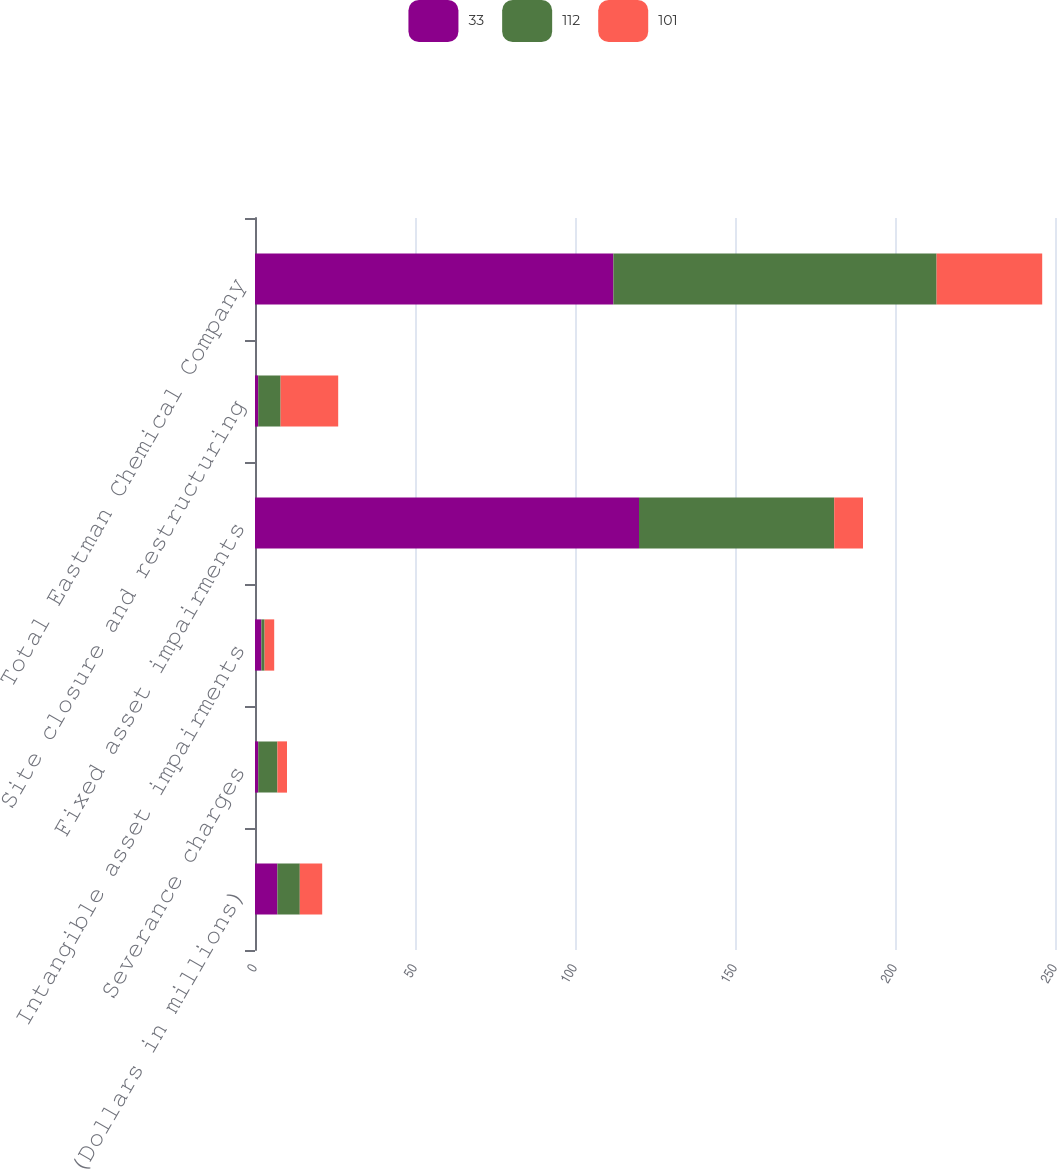Convert chart to OTSL. <chart><loc_0><loc_0><loc_500><loc_500><stacked_bar_chart><ecel><fcel>(Dollars in millions)<fcel>Severance charges<fcel>Intangible asset impairments<fcel>Fixed asset impairments<fcel>Site closure and restructuring<fcel>Total Eastman Chemical Company<nl><fcel>33<fcel>7<fcel>1<fcel>2<fcel>120<fcel>1<fcel>112<nl><fcel>112<fcel>7<fcel>6<fcel>1<fcel>61<fcel>7<fcel>101<nl><fcel>101<fcel>7<fcel>3<fcel>3<fcel>9<fcel>18<fcel>33<nl></chart> 